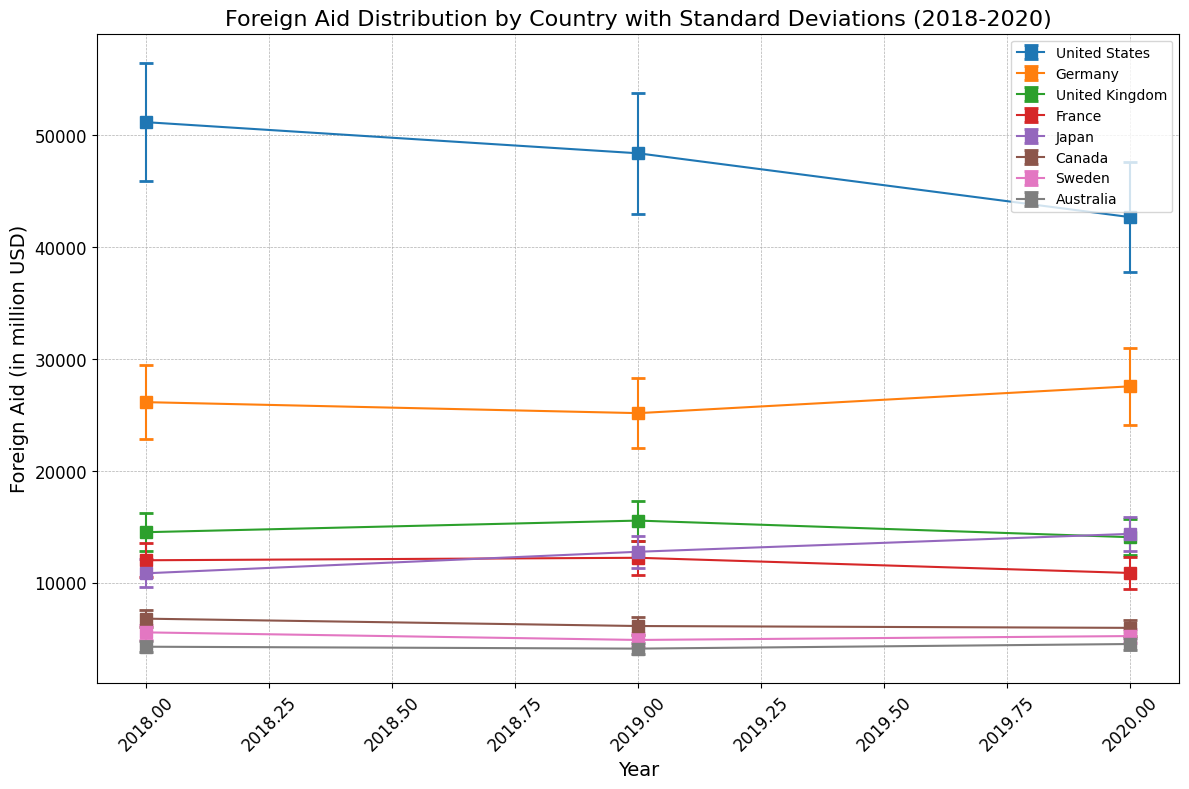What is the general trend of foreign aid from the United States from 2018 to 2020? The graph shows a decreasing trend in the foreign aid from the United States. In 2018, it was higher compared to 2020.
Answer: Decreasing Which country had the highest foreign aid in 2020? By looking at the heights of the markers for 2020, the United States had the highest foreign aid in 2020.
Answer: United States How does the foreign aid of Germany in 2019 compare to its foreign aid in 2018? By observing the markers for Germany in 2018 and 2019, Germany’s foreign aid slightly decreased from 26151 in 2018 to 25169 in 2019.
Answer: Decreased What is the total foreign aid provided by France over the 3 years? By summing the values for France from 2018, 2019, and 2020: 12013 + 12234 + 10876 = 35123.
Answer: 35123 Which two countries had nearly similar foreign aid distribution in 2020? Japan and Germany had quite close foreign aid values in 2020, with Germany at 27567 and Japan at 14373, considering the visual proximity of their markers.
Answer: Germany and Japan What is the difference in the foreign aid provided by the United Kingdom in 2019 and 2020? By subtracting the values: 15560 (2019) - 14076 (2020) = 1484.
Answer: 1484 Which country's foreign aid distribution shows the most fluctuation (variance) across the years 2018-2020? By observing the error bars, the United States has relatively larger standard deviations compared to other countries, indicating more fluctuation.
Answer: United States What is the average foreign aid from Canada across the years 2018 to 2020? Sum the foreign aid values from 2018, 2019, and 2020 and divide by 3: (6790 + 6132 + 5968) / 3 = 6296.67.
Answer: 6296.67 Which country had a decreasing trend without any intermediary increases from 2018 to 2020? By observing the trend lines, Sweden shows a consistent decrease without any intermediary increases from 2018 (5563) to 2019 (4887) and 2020 (5234).
Answer: Sweden Which country has the lowest foreign aid in 2018 and what is its value? By looking at the markers for 2018, Australia had the lowest foreign aid at 4281.
Answer: Australia, 4281 